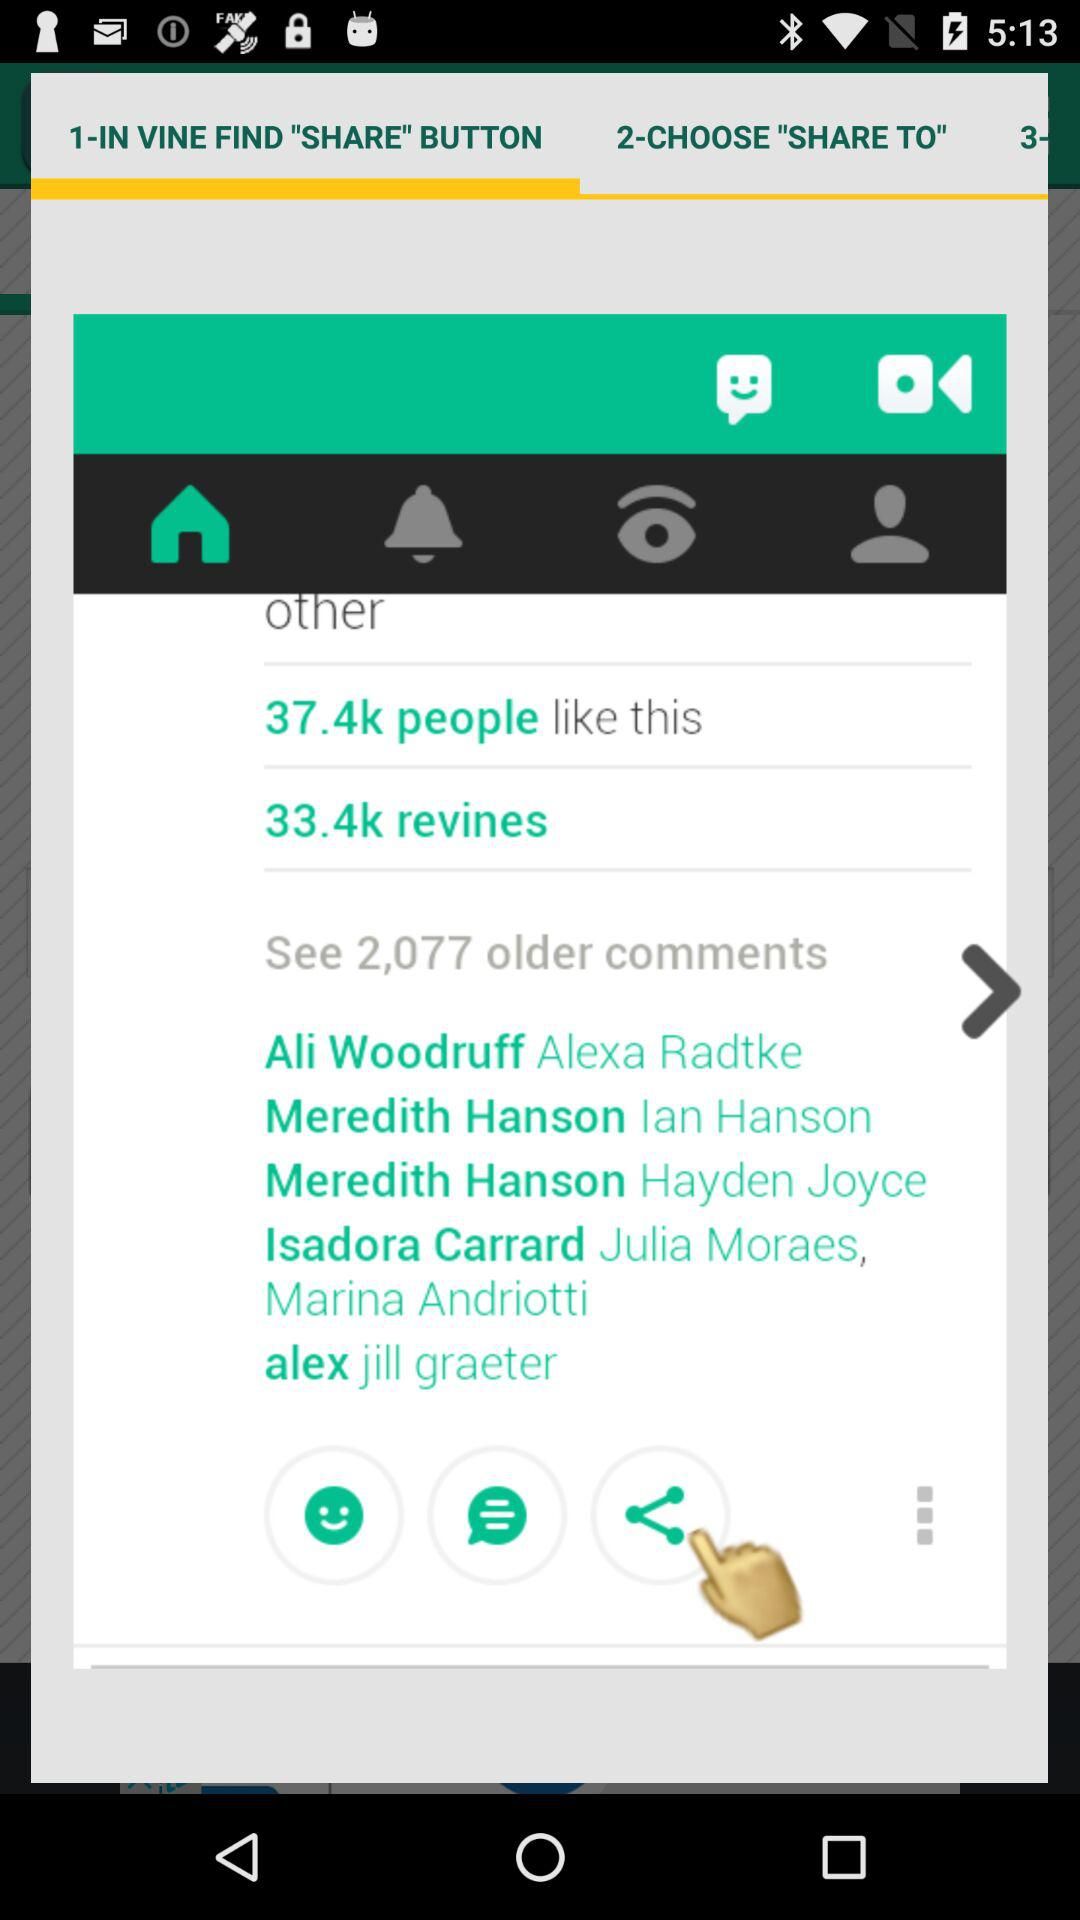How many likes are there? There are 37.4k likes. 